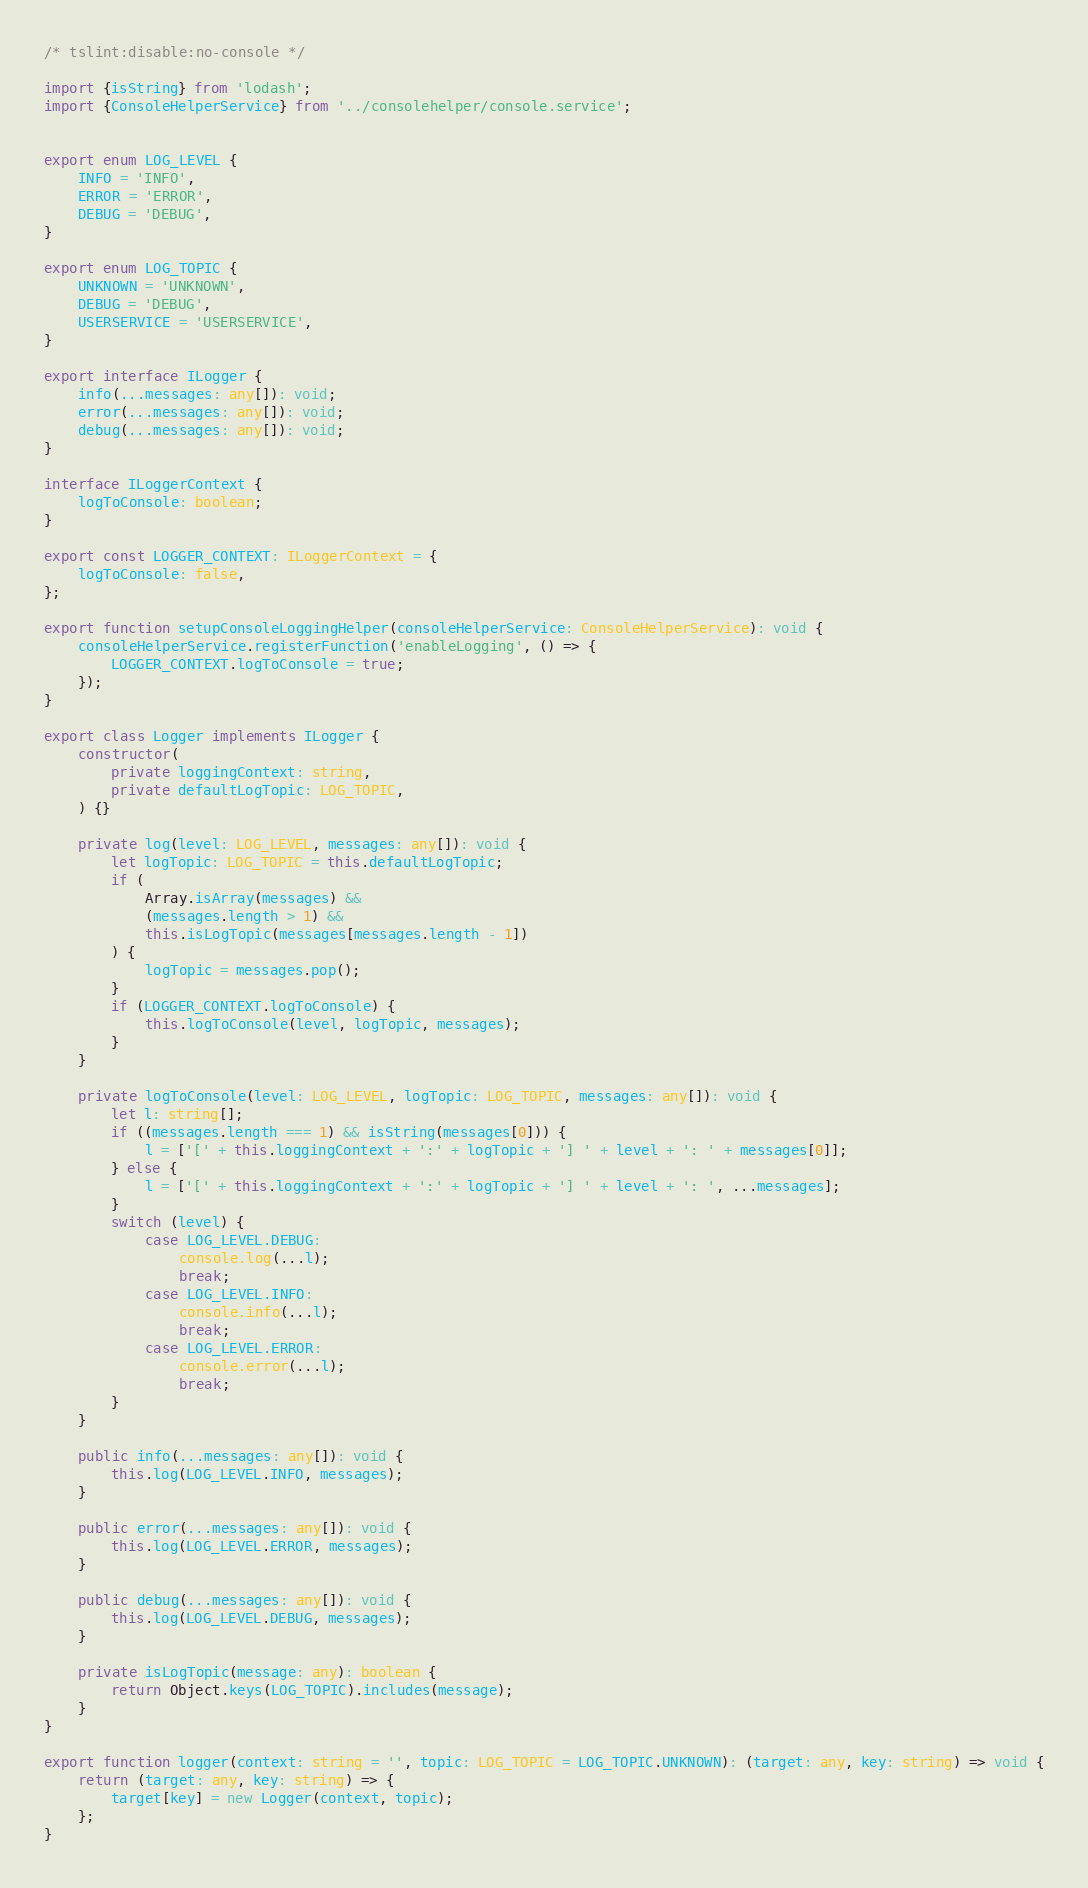Convert code to text. <code><loc_0><loc_0><loc_500><loc_500><_TypeScript_>/* tslint:disable:no-console */

import {isString} from 'lodash';
import {ConsoleHelperService} from '../consolehelper/console.service';


export enum LOG_LEVEL {
    INFO = 'INFO',
    ERROR = 'ERROR',
    DEBUG = 'DEBUG',
}

export enum LOG_TOPIC {
    UNKNOWN = 'UNKNOWN',
    DEBUG = 'DEBUG',
    USERSERVICE = 'USERSERVICE',
}

export interface ILogger {
    info(...messages: any[]): void;
    error(...messages: any[]): void;
    debug(...messages: any[]): void;
}

interface ILoggerContext {
    logToConsole: boolean;
}

export const LOGGER_CONTEXT: ILoggerContext = {
    logToConsole: false,
};

export function setupConsoleLoggingHelper(consoleHelperService: ConsoleHelperService): void {
    consoleHelperService.registerFunction('enableLogging', () => {
        LOGGER_CONTEXT.logToConsole = true;
    });
}

export class Logger implements ILogger {
    constructor(
        private loggingContext: string,
        private defaultLogTopic: LOG_TOPIC,
    ) {}

    private log(level: LOG_LEVEL, messages: any[]): void {
        let logTopic: LOG_TOPIC = this.defaultLogTopic;
        if (
            Array.isArray(messages) &&
            (messages.length > 1) &&
            this.isLogTopic(messages[messages.length - 1])
        ) {
            logTopic = messages.pop();
        }
        if (LOGGER_CONTEXT.logToConsole) {
            this.logToConsole(level, logTopic, messages);
        }
    }

    private logToConsole(level: LOG_LEVEL, logTopic: LOG_TOPIC, messages: any[]): void {
        let l: string[];
        if ((messages.length === 1) && isString(messages[0])) {
            l = ['[' + this.loggingContext + ':' + logTopic + '] ' + level + ': ' + messages[0]];
        } else {
            l = ['[' + this.loggingContext + ':' + logTopic + '] ' + level + ': ', ...messages];
        }
        switch (level) {
            case LOG_LEVEL.DEBUG:
                console.log(...l);
                break;
            case LOG_LEVEL.INFO:
                console.info(...l);
                break;
            case LOG_LEVEL.ERROR:
                console.error(...l);
                break;
        }
    }

    public info(...messages: any[]): void {
        this.log(LOG_LEVEL.INFO, messages);
    }

    public error(...messages: any[]): void {
        this.log(LOG_LEVEL.ERROR, messages);
    }

    public debug(...messages: any[]): void {
        this.log(LOG_LEVEL.DEBUG, messages);
    }

    private isLogTopic(message: any): boolean {
        return Object.keys(LOG_TOPIC).includes(message);
    }
}

export function logger(context: string = '', topic: LOG_TOPIC = LOG_TOPIC.UNKNOWN): (target: any, key: string) => void {
    return (target: any, key: string) => {
        target[key] = new Logger(context, topic);
    };
}
</code> 